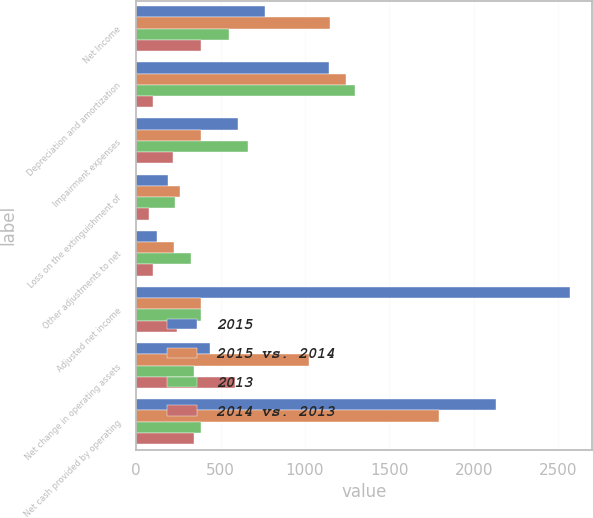<chart> <loc_0><loc_0><loc_500><loc_500><stacked_bar_chart><ecel><fcel>Net Income<fcel>Depreciation and amortization<fcel>Impairment expenses<fcel>Loss on the extinguishment of<fcel>Other adjustments to net<fcel>Adjusted net income<fcel>Net change in operating assets<fcel>Net cash provided by operating<nl><fcel>2015<fcel>762<fcel>1144<fcel>602<fcel>186<fcel>123<fcel>2571<fcel>437<fcel>2134<nl><fcel>2015 vs. 2014<fcel>1147<fcel>1245<fcel>383<fcel>261<fcel>223<fcel>385<fcel>1022<fcel>1791<nl><fcel>2013<fcel>551<fcel>1294<fcel>661<fcel>229<fcel>324<fcel>385<fcel>344<fcel>385<nl><fcel>2014 vs. 2013<fcel>385<fcel>101<fcel>219<fcel>75<fcel>100<fcel>242<fcel>585<fcel>343<nl></chart> 